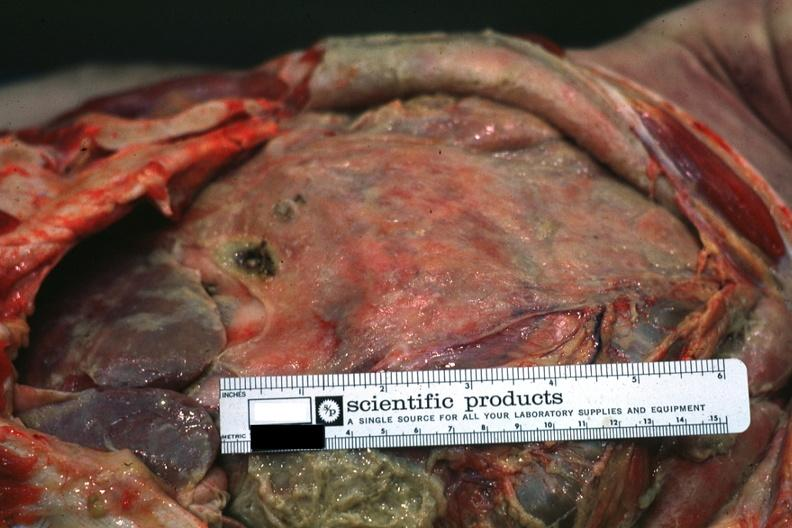s abdomen present?
Answer the question using a single word or phrase. Yes 